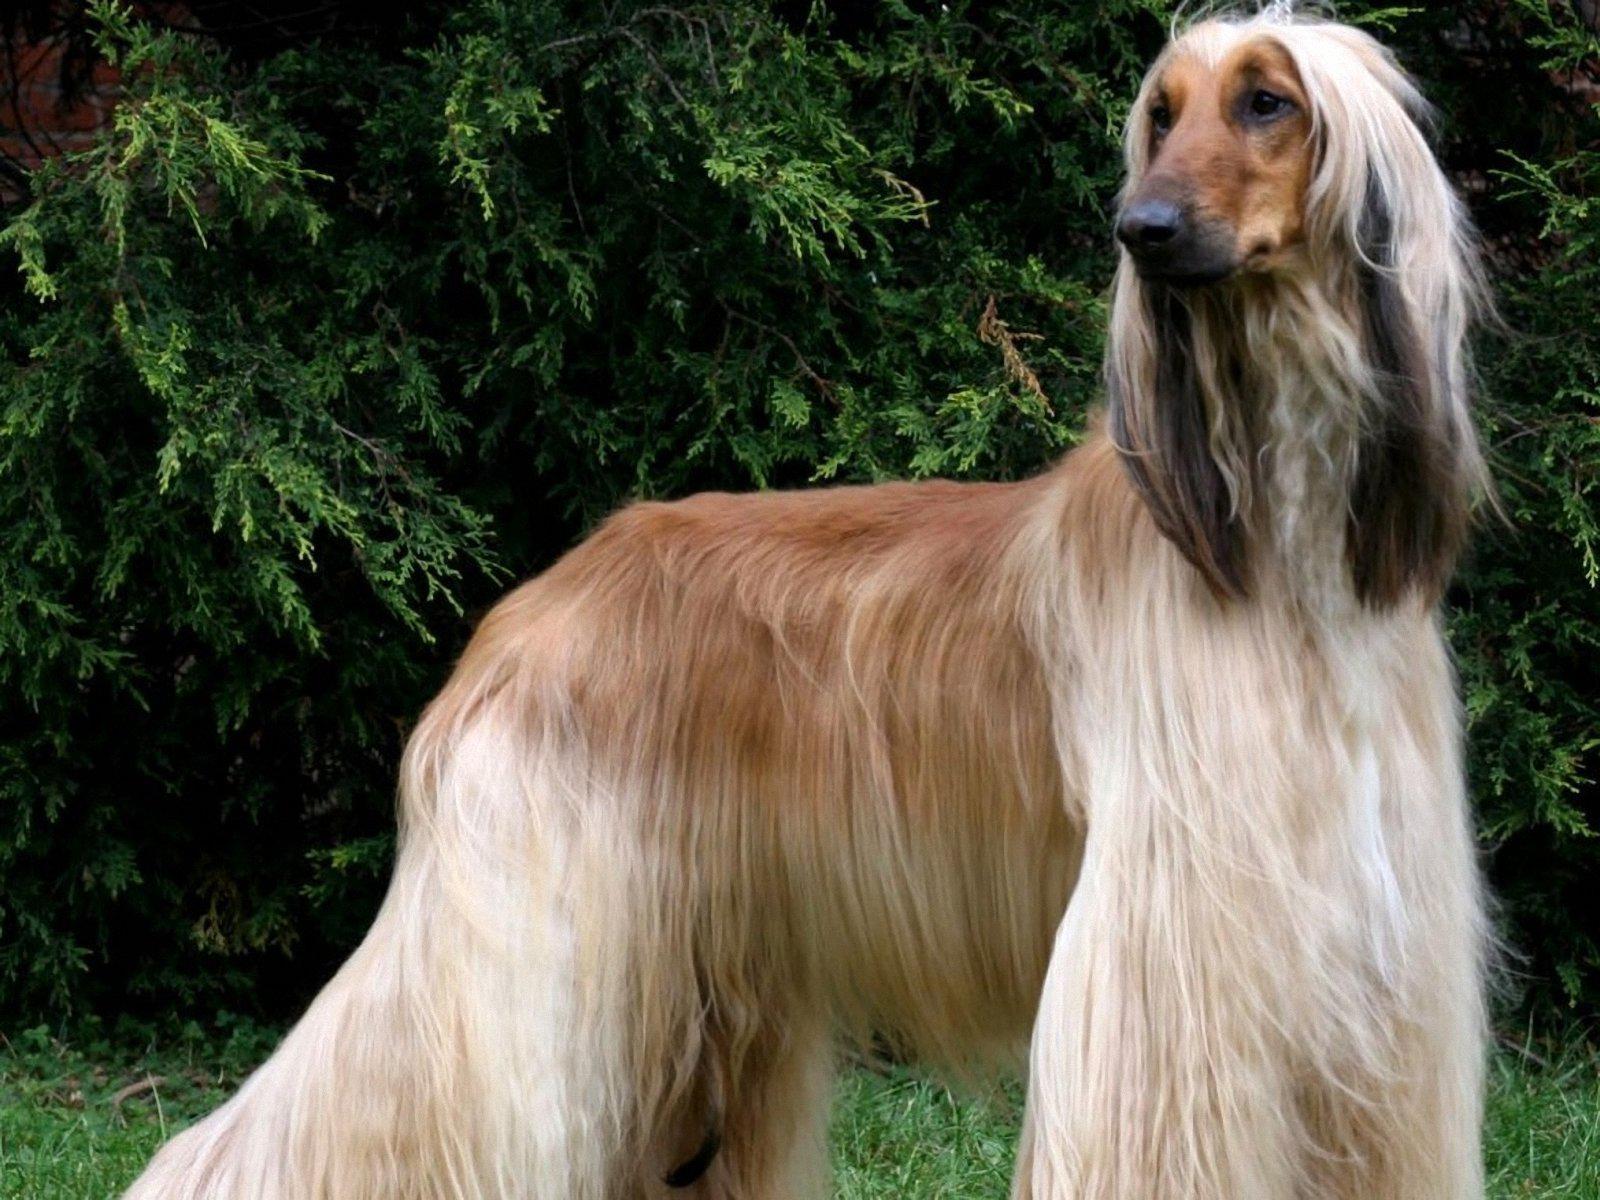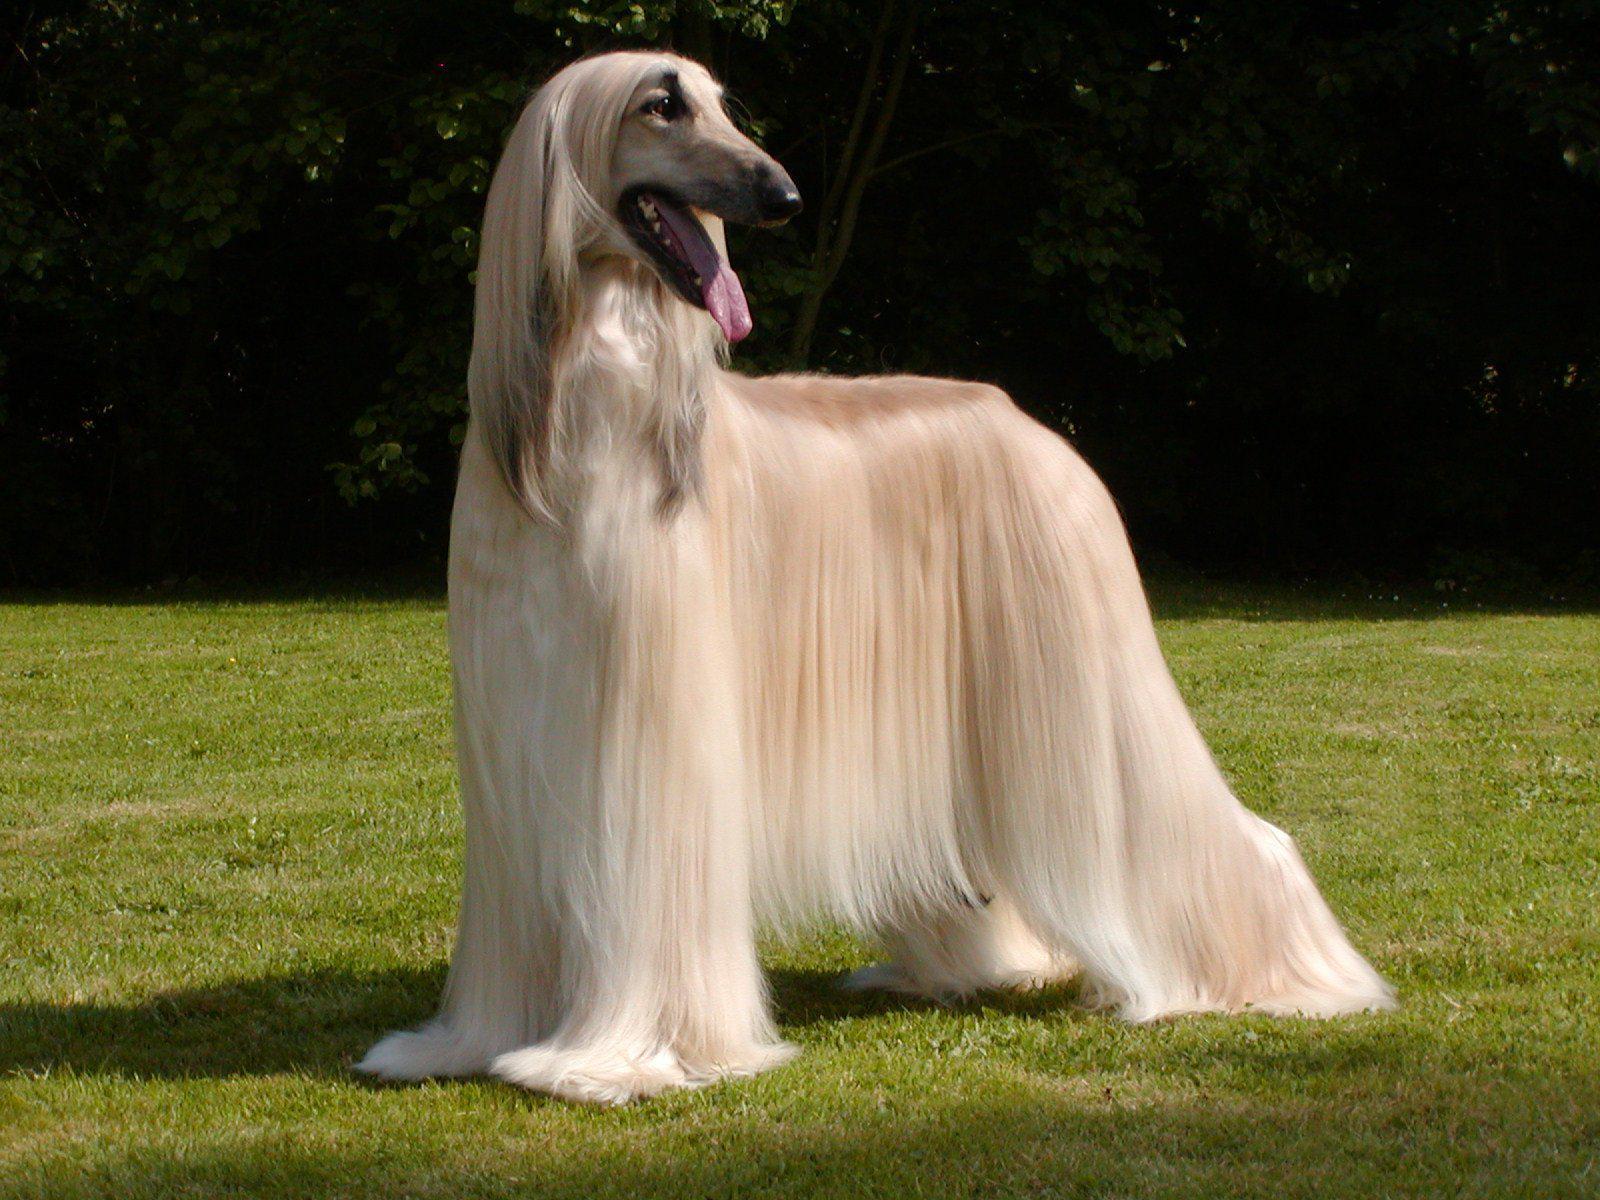The first image is the image on the left, the second image is the image on the right. Evaluate the accuracy of this statement regarding the images: "All the dogs pictured are standing on the grass.". Is it true? Answer yes or no. Yes. 